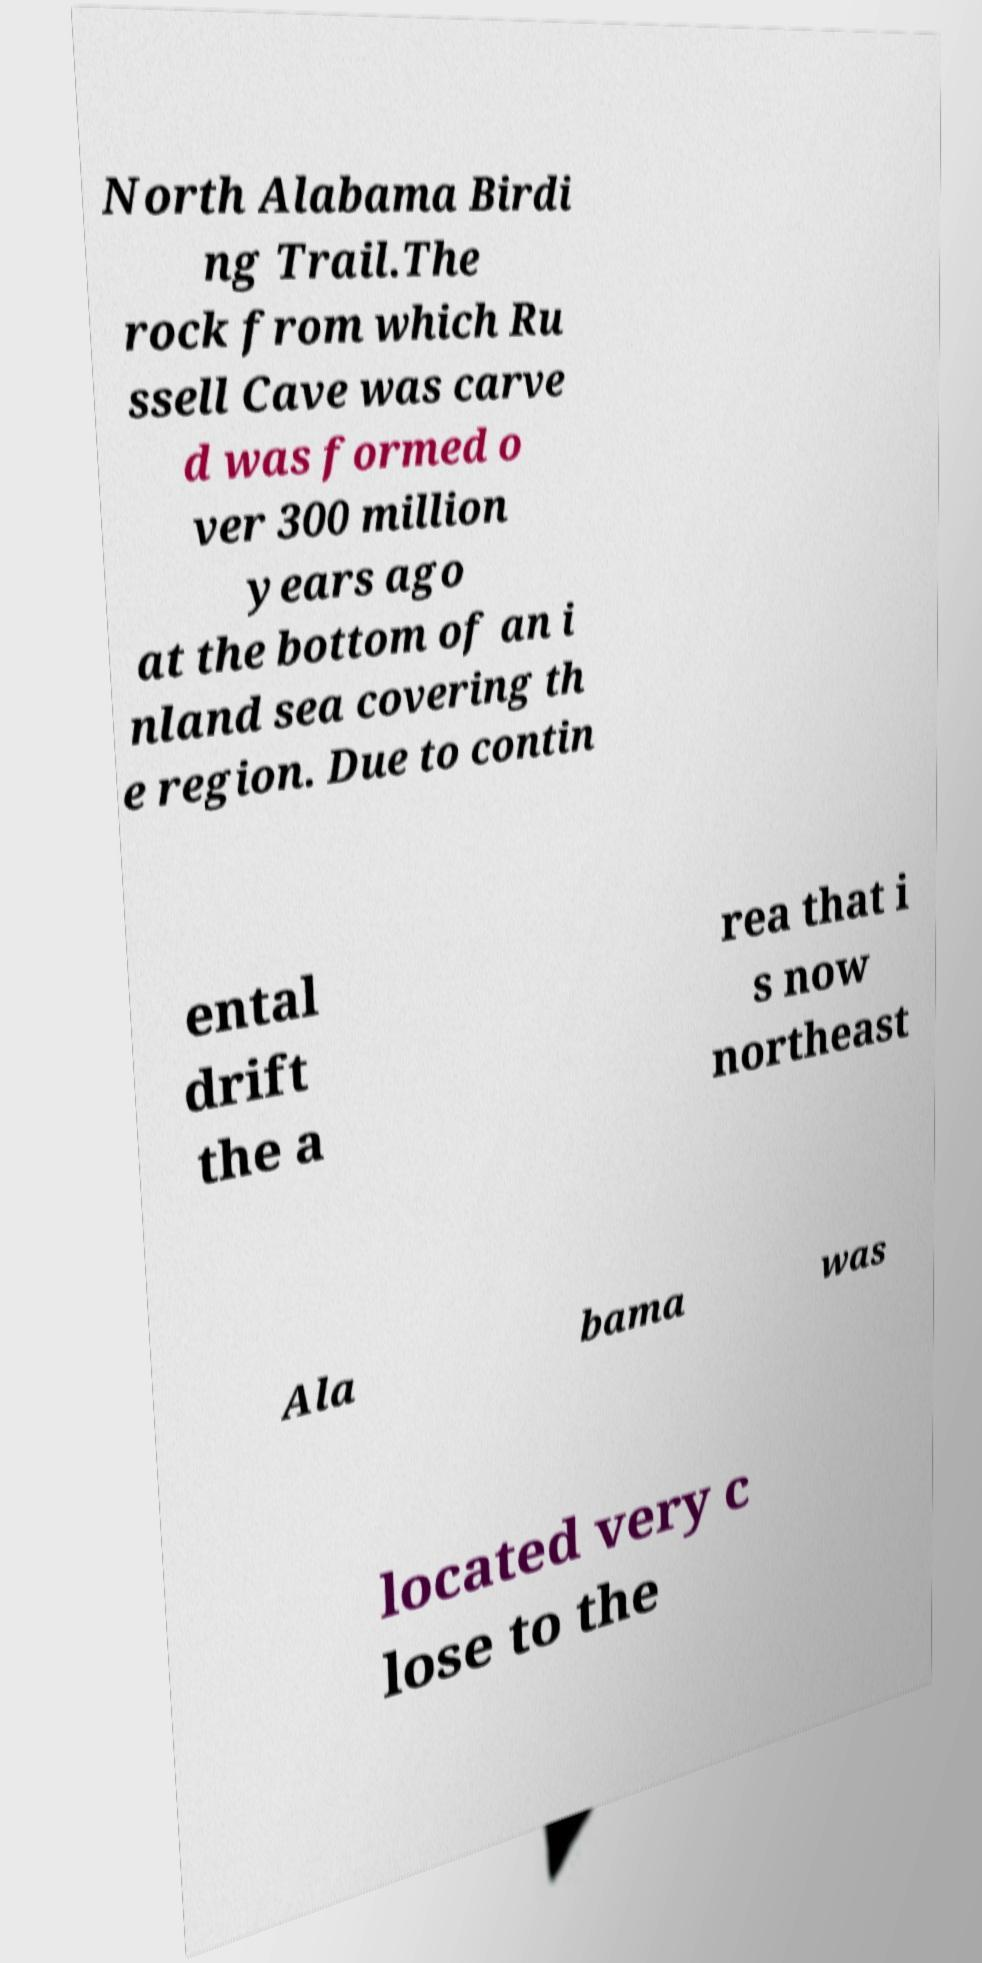Could you assist in decoding the text presented in this image and type it out clearly? North Alabama Birdi ng Trail.The rock from which Ru ssell Cave was carve d was formed o ver 300 million years ago at the bottom of an i nland sea covering th e region. Due to contin ental drift the a rea that i s now northeast Ala bama was located very c lose to the 